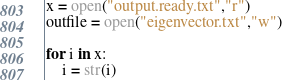Convert code to text. <code><loc_0><loc_0><loc_500><loc_500><_Python_>x = open("output.ready.txt","r")
outfile = open("eigenvector.txt","w")

for i in x:
	i = str(i)</code> 